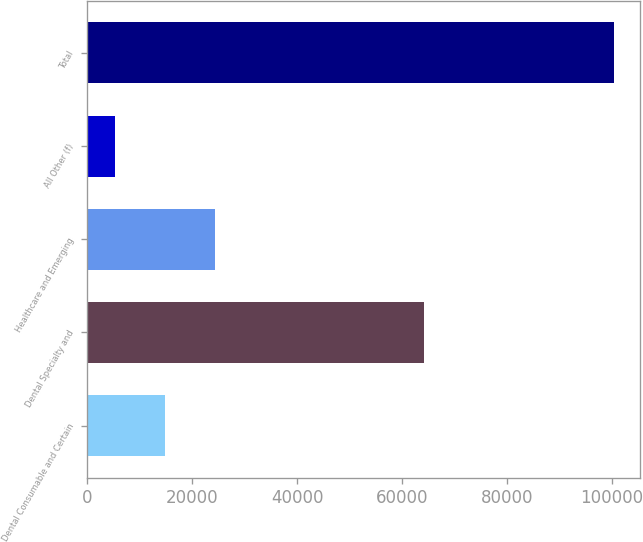<chart> <loc_0><loc_0><loc_500><loc_500><bar_chart><fcel>Dental Consumable and Certain<fcel>Dental Specialty and<fcel>Healthcare and Emerging<fcel>All Other (f)<fcel>Total<nl><fcel>14821.6<fcel>64084<fcel>24324.2<fcel>5319<fcel>100345<nl></chart> 